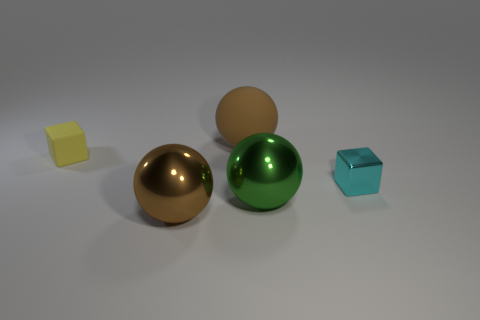There is a tiny matte object; does it have the same shape as the large metallic thing left of the brown rubber ball?
Give a very brief answer. No. What is the shape of the big thing behind the small cyan metal block to the right of the small object that is behind the tiny cyan object?
Provide a succinct answer. Sphere. How many other objects are the same material as the cyan thing?
Offer a terse response. 2. What number of things are either large brown spheres in front of the cyan cube or yellow spheres?
Offer a terse response. 1. What is the shape of the yellow matte thing that is left of the small cube that is right of the brown rubber sphere?
Your answer should be compact. Cube. Is the shape of the big object left of the big rubber thing the same as  the tiny yellow rubber object?
Offer a very short reply. No. What is the color of the ball that is behind the matte block?
Your answer should be compact. Brown. How many cylinders are large cyan matte objects or cyan objects?
Make the answer very short. 0. How big is the brown thing on the left side of the matte thing behind the yellow object?
Your answer should be compact. Large. There is a metallic cube; is its color the same as the small block left of the tiny cyan object?
Your answer should be compact. No. 